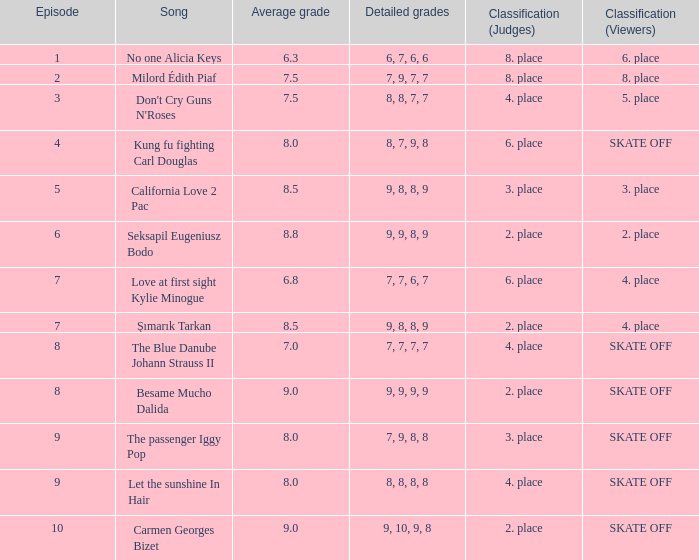Name the classification for 9, 9, 8, 9 2. place. 